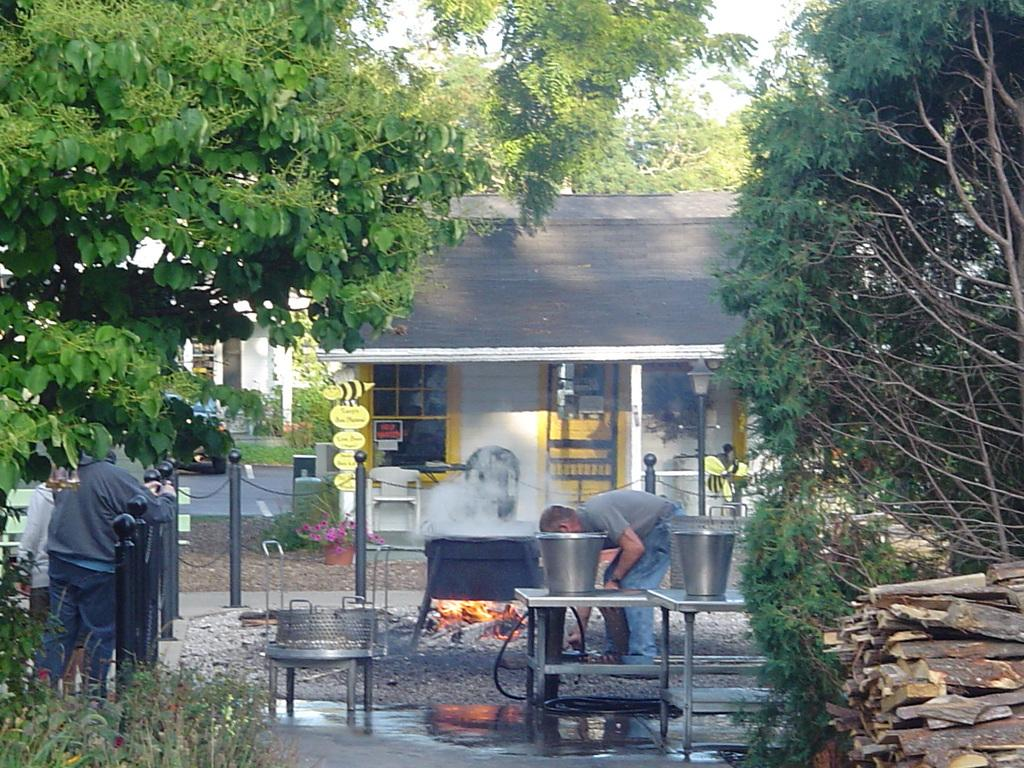How many people are present in the image? There are people in the image, but the exact number is not specified. What type of barrier can be seen in the image? There is a fence in the image. What type of vegetation is present in the image? There are plants, trees, and flowers in the image. What type of structure is visible in the image? There is: There is a house in the image. What type of furniture is present in the image? There are tables in the image. What type of material is present in the image? There are wooden sticks in the image. What type of container is present in the image? There are buckets in the image. What type of scarf is being used to design the house in the image? There is no mention of a scarf being used to design the house in the image. How does the digestion of the wooden sticks affect the growth of the plants in the image? There is no information about the digestion of wooden sticks or their effect on plant growth in the image. 